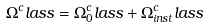Convert formula to latex. <formula><loc_0><loc_0><loc_500><loc_500>\Omega ^ { c } l a s s = \Omega _ { 0 } ^ { c } l a s s + \Omega _ { i n s t } ^ { c } l a s s</formula> 